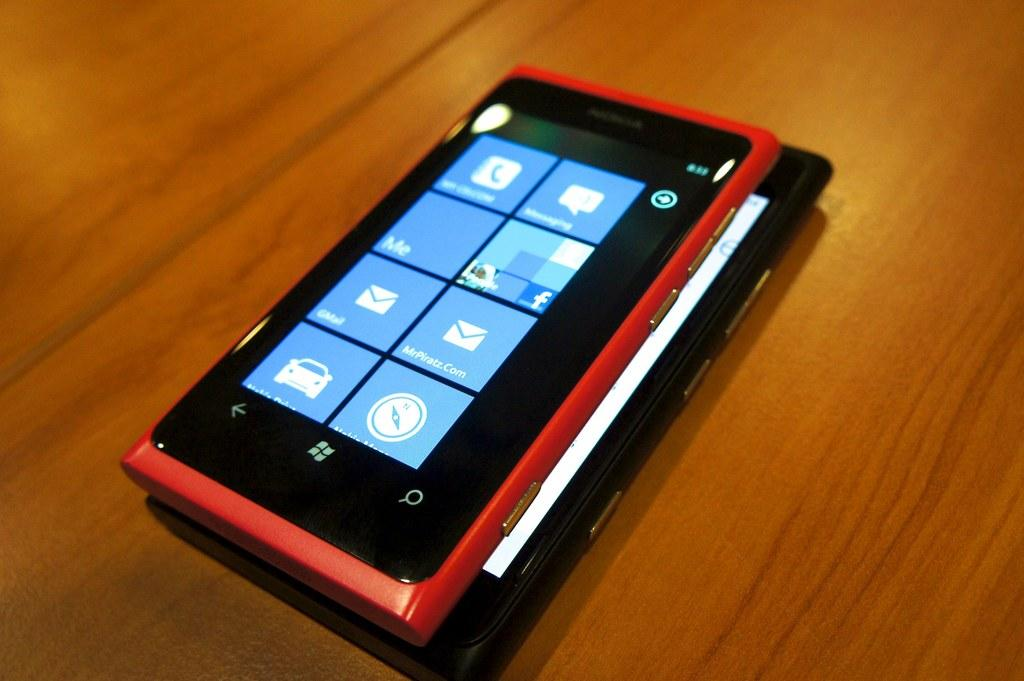<image>
Provide a brief description of the given image. software apps on a cell phone such as mrpiratz.com and gmail 